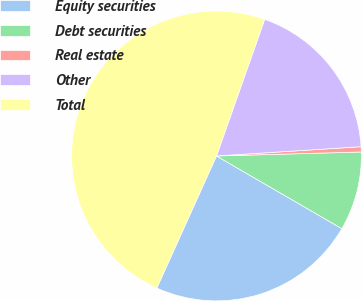<chart> <loc_0><loc_0><loc_500><loc_500><pie_chart><fcel>Equity securities<fcel>Debt securities<fcel>Real estate<fcel>Other<fcel>Total<nl><fcel>23.39%<fcel>8.8%<fcel>0.58%<fcel>18.58%<fcel>48.64%<nl></chart> 